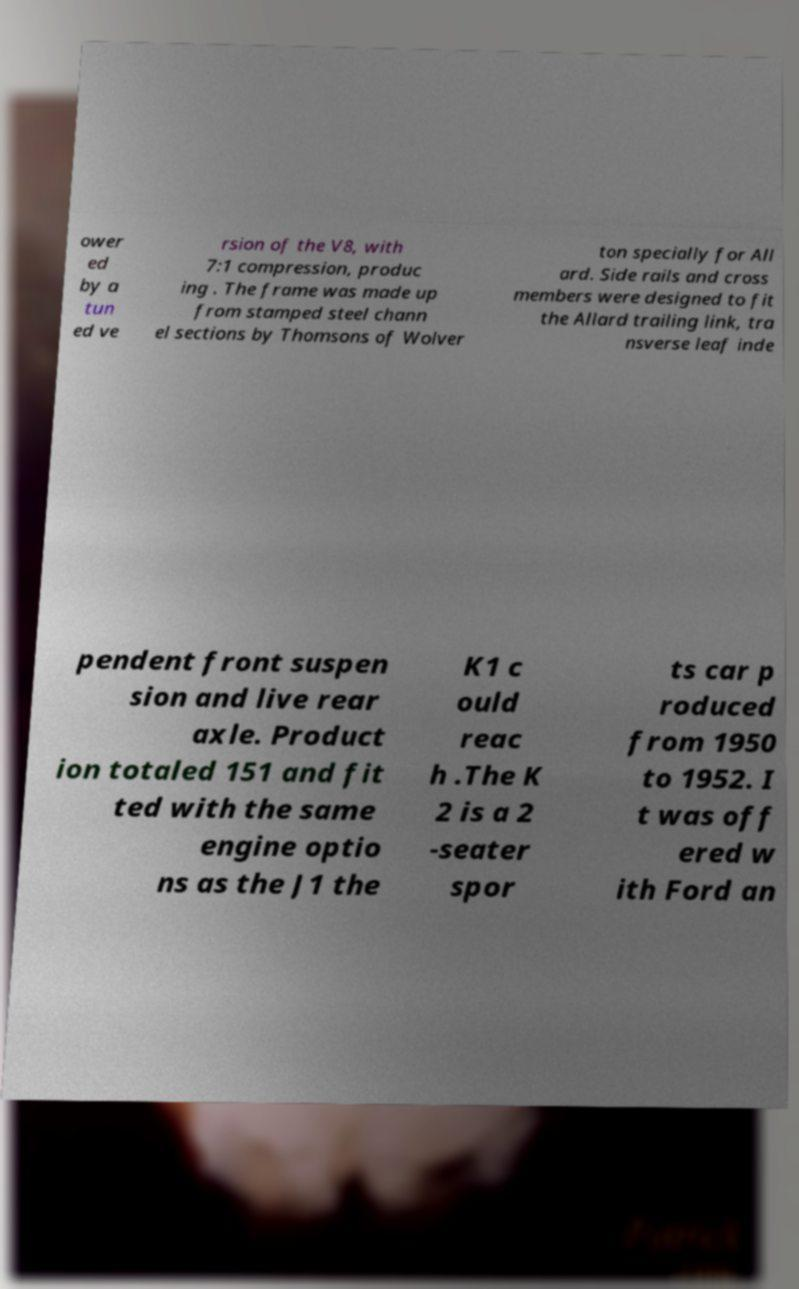Please read and relay the text visible in this image. What does it say? ower ed by a tun ed ve rsion of the V8, with 7:1 compression, produc ing . The frame was made up from stamped steel chann el sections by Thomsons of Wolver ton specially for All ard. Side rails and cross members were designed to fit the Allard trailing link, tra nsverse leaf inde pendent front suspen sion and live rear axle. Product ion totaled 151 and fit ted with the same engine optio ns as the J1 the K1 c ould reac h .The K 2 is a 2 -seater spor ts car p roduced from 1950 to 1952. I t was off ered w ith Ford an 